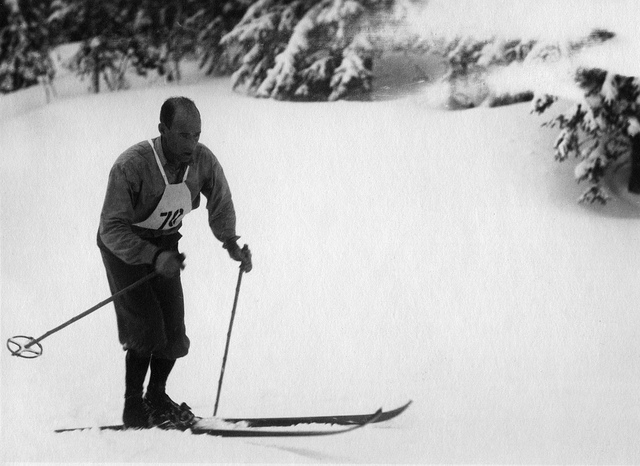Please identify all text content in this image. 70 